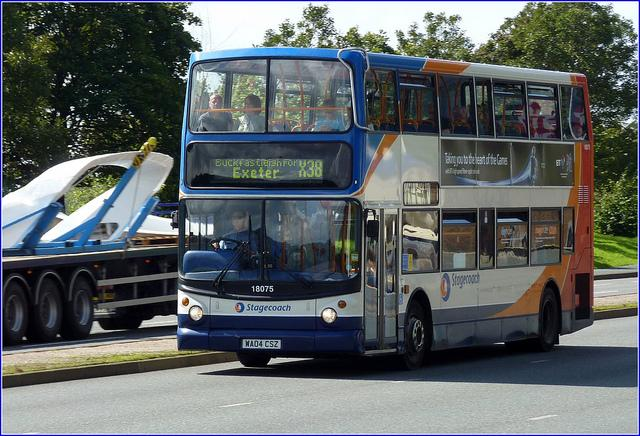In which country does this bus travel? england 